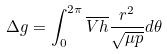Convert formula to latex. <formula><loc_0><loc_0><loc_500><loc_500>\Delta g = \int _ { 0 } ^ { 2 \pi } \overline { V } \overline { h } \frac { r ^ { 2 } } { \sqrt { \mu p } } d \theta</formula> 